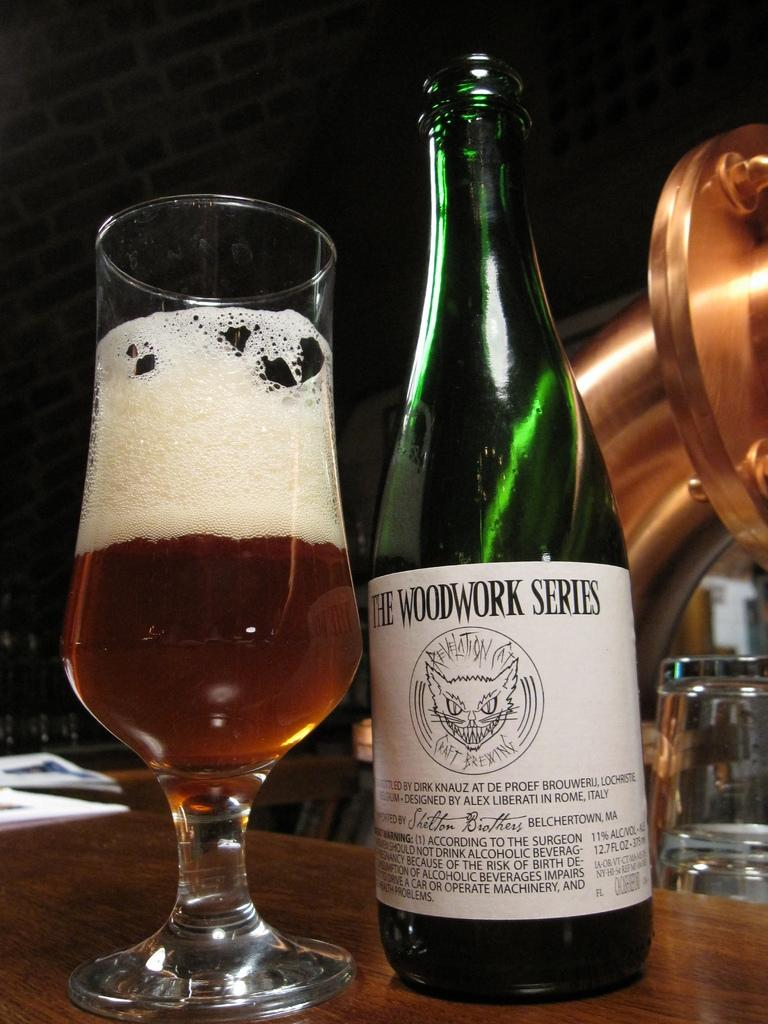Provide a one-sentence caption for the provided image. An open ale bottle of The Woodwork Series next to a half full glass. 